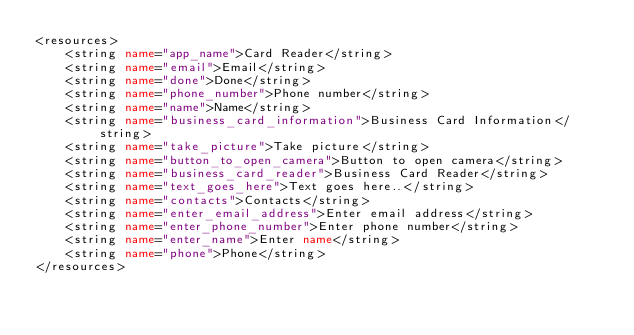<code> <loc_0><loc_0><loc_500><loc_500><_XML_><resources>
    <string name="app_name">Card Reader</string>
    <string name="email">Email</string>
    <string name="done">Done</string>
    <string name="phone_number">Phone number</string>
    <string name="name">Name</string>
    <string name="business_card_information">Business Card Information</string>
    <string name="take_picture">Take picture</string>
    <string name="button_to_open_camera">Button to open camera</string>
    <string name="business_card_reader">Business Card Reader</string>
    <string name="text_goes_here">Text goes here..</string>
    <string name="contacts">Contacts</string>
    <string name="enter_email_address">Enter email address</string>
    <string name="enter_phone_number">Enter phone number</string>
    <string name="enter_name">Enter name</string>
    <string name="phone">Phone</string>
</resources>
</code> 